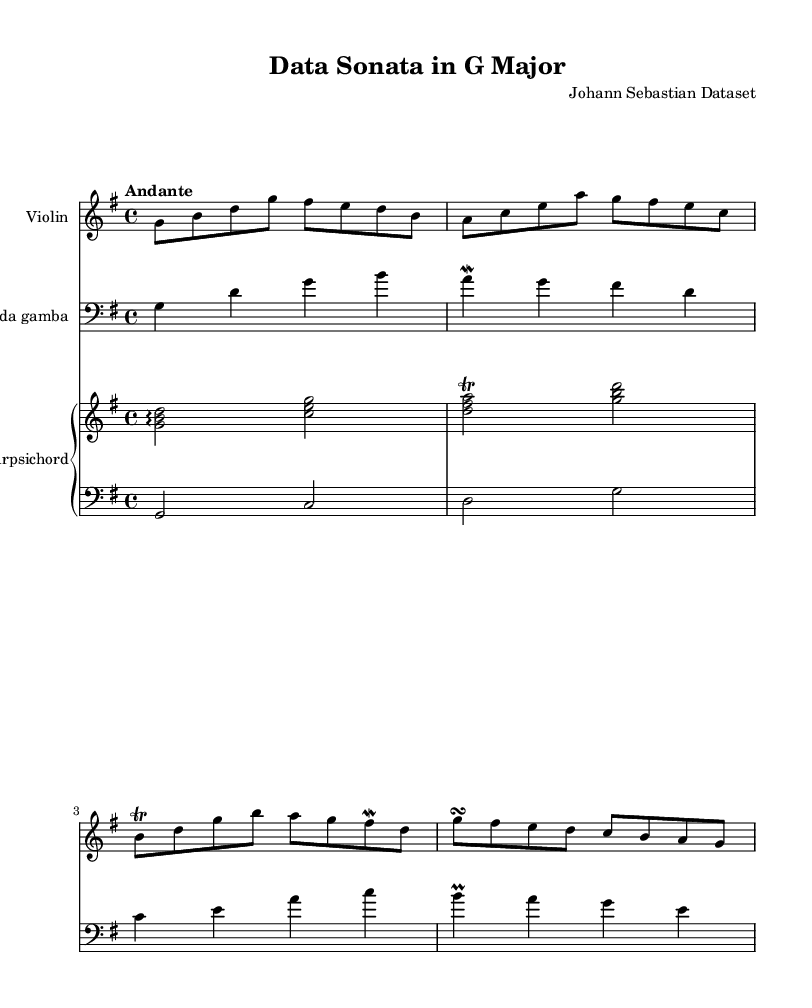What is the key signature of this music? The key signature is G major, which has one sharp (F#) indicated at the beginning of the staff.
Answer: G major What is the time signature of this music? The time signature is 4/4, which indicates four beats per measure, with each quarter note receiving one beat.
Answer: 4/4 What is the tempo marking of the piece? The tempo marking is "Andante," which suggests a moderate walking pace, typically around 76 to 108 beats per minute.
Answer: Andante How many measures are there in the violin part? Counting the measures presented in the violin part, there are a total of four measures available.
Answer: Four Which instruments are used in this chamber music? The instruments used are Violin, Viola da gamba, and Harpsichord, as indicated by their respective staff names in the score.
Answer: Violin, Viola da gamba, Harpsichord What type of ornamentation is featured prominently in the violin part? The violin part features a trill and a mordent that are specific types of ornamentation typical in Baroque music, enhancing the melodic line.
Answer: Trill and mordent What is the texture of the piece based on the instrumentation? The texture is homophonic, as the focus is primarily on the melody played by the violin, supported by harmonic accompaniment from the viola da gamba and the harpsichord.
Answer: Homophonic 